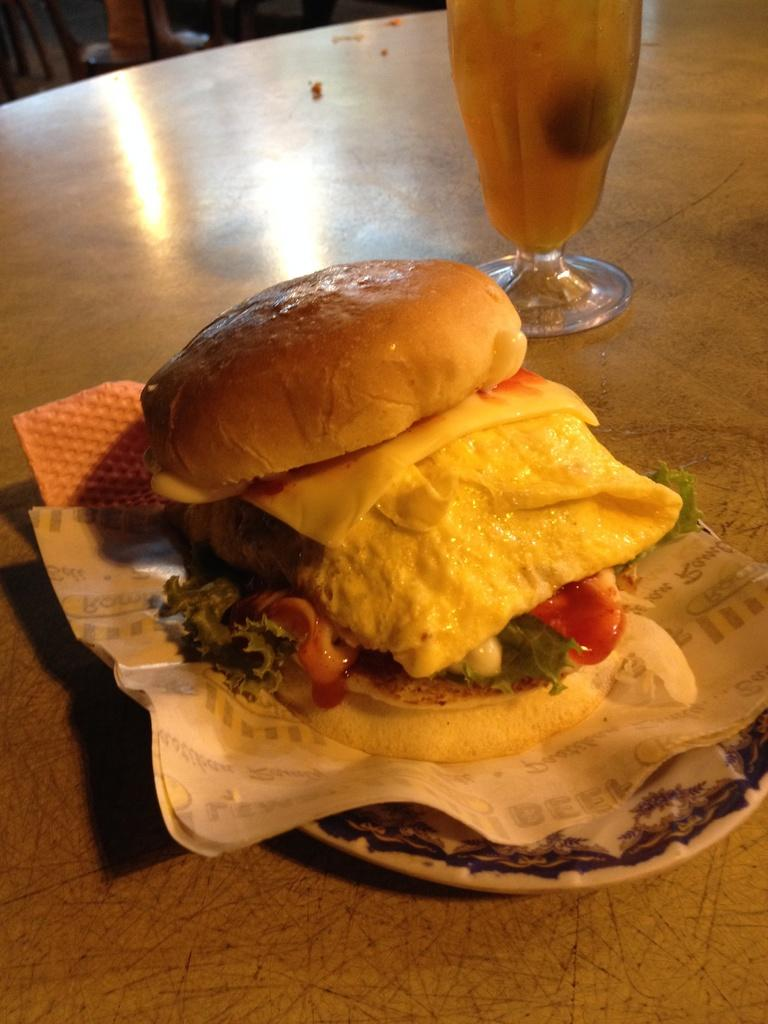What is on the plate that is visible in the image? There is a plate containing food in the image. What else is present on the surface in the image? There is a paper placed on the surface in the image. What is in the glass that is visible in the image? There is a glass containing liquid in the image. Can you hear the whistle in the image? There is no whistle present in the image. How many hands are visible in the image? There is no mention of hands in the image. 